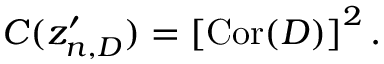Convert formula to latex. <formula><loc_0><loc_0><loc_500><loc_500>C ( z _ { n , D } ^ { \prime } ) = \left [ C o r ( D ) \right ] ^ { 2 } .</formula> 